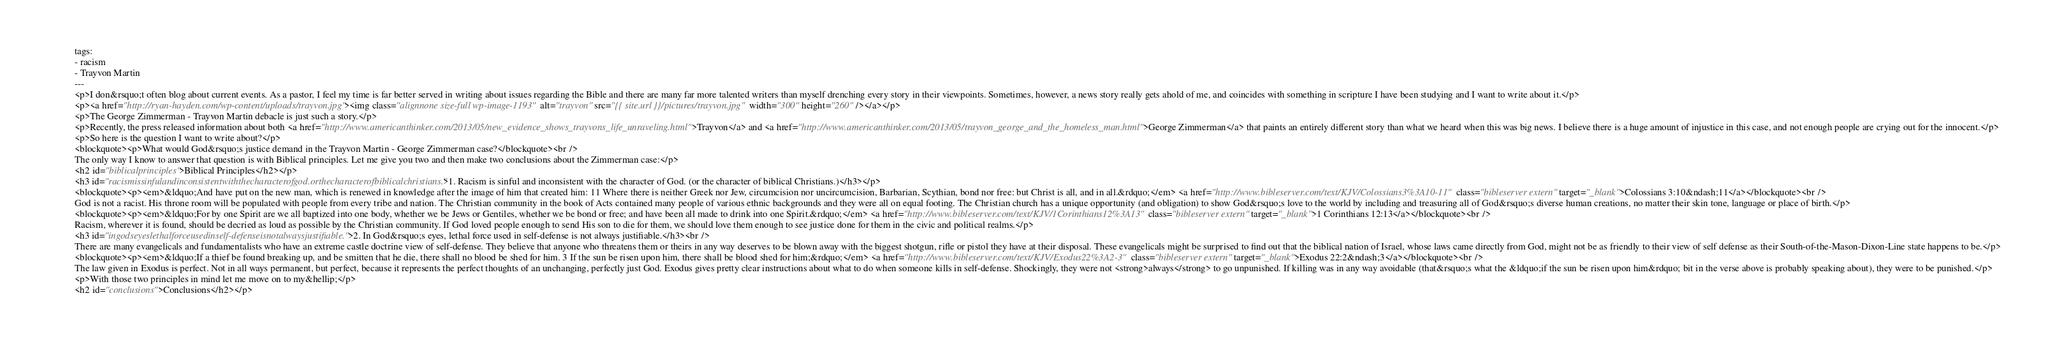Convert code to text. <code><loc_0><loc_0><loc_500><loc_500><_HTML_>tags:
- racism
- Trayvon Martin
---
<p>I don&rsquo;t often blog about current events. As a pastor, I feel my time is far better served in writing about issues regarding the Bible and there are many far more talented writers than myself drenching every story in their viewpoints. Sometimes, however, a news story really gets ahold of me, and coincides with something in scripture I have been studying and I want to write about it.</p>
<p><a href="http://ryan-hayden.com/wp-content/uploads/trayvon.jpg"><img class="alignnone size-full wp-image-1193" alt="trayvon" src="{{ site.url }}/pictures/trayvon.jpg" width="300" height="260" /></a></p>
<p>The George Zimmerman - Trayvon Martin debacle is just such a story.</p>
<p>Recently, the press released information about both <a href="http://www.americanthinker.com/2013/05/new_evidence_shows_trayvons_life_unraveling.html">Trayvon</a> and <a href="http://www.americanthinker.com/2013/05/trayvon_george_and_the_homeless_man.html">George Zimmerman</a> that paints an entirely different story than what we heard when this was big news. I believe there is a huge amount of injustice in this case, and not enough people are crying out for the innocent.</p>
<p>So here is the question I want to write about?</p>
<blockquote><p>What would God&rsquo;s justice demand in the Trayvon Martin - George Zimmerman case?</blockquote><br />
The only way I know to answer that question is with Biblical principles. Let me give you two and then make two conclusions about the Zimmerman case:</p>
<h2 id="biblicalprinciples">Biblical Principles</h2></p>
<h3 id="racismissinfulandinconsistentwiththecharacterofgod.orthecharacterofbiblicalchristians.">1. Racism is sinful and inconsistent with the character of God. (or the character of biblical Christians.)</h3></p>
<blockquote><p><em>&ldquo;And have put on the new man, which is renewed in knowledge after the image of him that created him: 11 Where there is neither Greek nor Jew, circumcision nor uncircumcision, Barbarian, Scythian, bond nor free: but Christ is all, and in all.&rdquo;</em> <a href="http://www.bibleserver.com/text/KJV/Colossians3%3A10-11" class="bibleserver extern" target="_blank">Colossians 3:10&ndash;11</a></blockquote><br />
God is not a racist. His throne room will be populated with people from every tribe and nation. The Christian community in the book of Acts contained many people of various ethnic backgrounds and they were all on equal footing. The Christian church has a unique opportunity (and obligation) to show God&rsquo;s love to the world by including and treasuring all of God&rsquo;s diverse human creations, no matter their skin tone, language or place of birth.</p>
<blockquote><p><em>&ldquo;For by one Spirit are we all baptized into one body, whether we be Jews or Gentiles, whether we be bond or free; and have been all made to drink into one Spirit.&rdquo;</em> <a href="http://www.bibleserver.com/text/KJV/1Corinthians12%3A13" class="bibleserver extern" target="_blank">1 Corinthians 12:13</a></blockquote><br />
Racism, wherever it is found, should be decried as loud as possible by the Christian community. If God loved people enough to send His son to die for them, we should love them enough to see justice done for them in the civic and political realms.</p>
<h3 id="ingodseyeslethalforceusedinself-defenseisnotalwaysjustifiable.">2. In God&rsquo;s eyes, lethal force used in self-defense is not always justifiable.</h3><br />
There are many evangelicals and fundamentalists who have an extreme castle doctrine view of self-defense. They believe that anyone who threatens them or theirs in any way deserves to be blown away with the biggest shotgun, rifle or pistol they have at their disposal. These evangelicals might be surprised to find out that the biblical nation of Israel, whose laws came directly from God, might not be as friendly to their view of self defense as their South-of-the-Mason-Dixon-Line state happens to be.</p>
<blockquote><p><em>&ldquo;If a thief be found breaking up, and be smitten that he die, there shall no blood be shed for him. 3 If the sun be risen upon him, there shall be blood shed for him;&rdquo;</em> <a href="http://www.bibleserver.com/text/KJV/Exodus22%3A2-3" class="bibleserver extern" target="_blank">Exodus 22:2&ndash;3</a></blockquote><br />
The law given in Exodus is perfect. Not in all ways permanent, but perfect, because it represents the perfect thoughts of an unchanging, perfectly just God. Exodus gives pretty clear instructions about what to do when someone kills in self-defense. Shockingly, they were not <strong>always</strong> to go unpunished. If killing was in any way avoidable (that&rsquo;s what the &ldquo;if the sun be risen upon him&rdquo; bit in the verse above is probably speaking about), they were to be punished.</p>
<p>With those two principles in mind let me move on to my&hellip;</p>
<h2 id="conclusions">Conclusions</h2></p></code> 